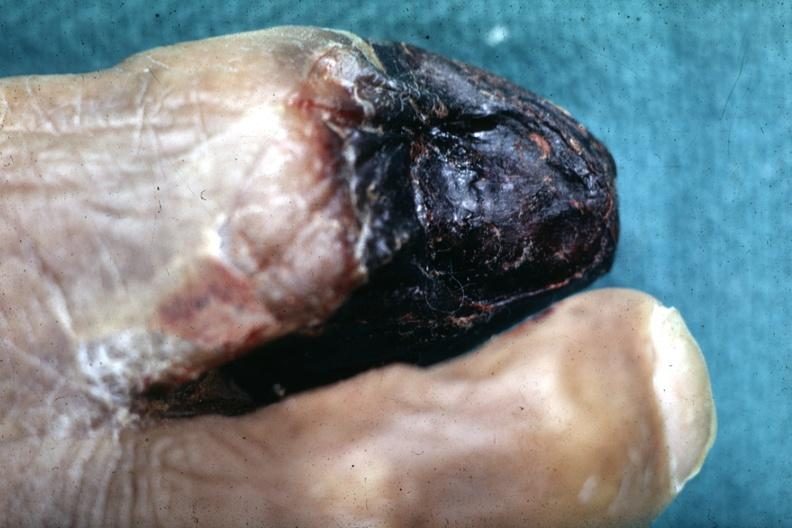what is present?
Answer the question using a single word or phrase. Feet 